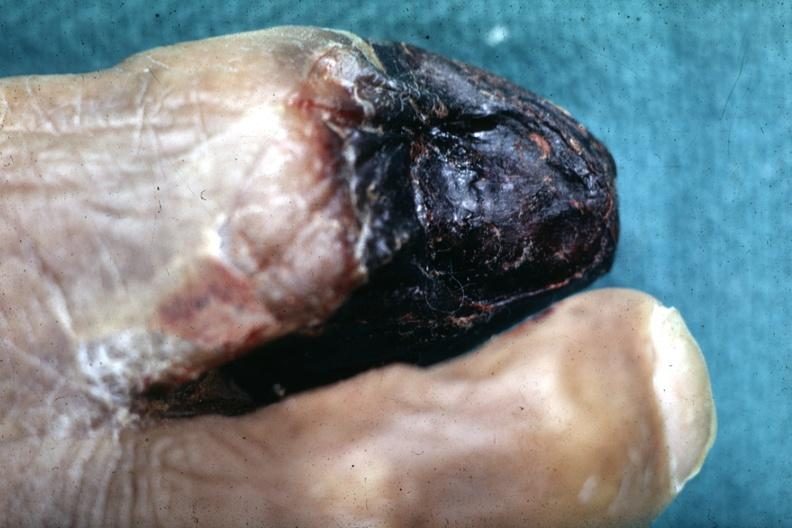what is present?
Answer the question using a single word or phrase. Feet 